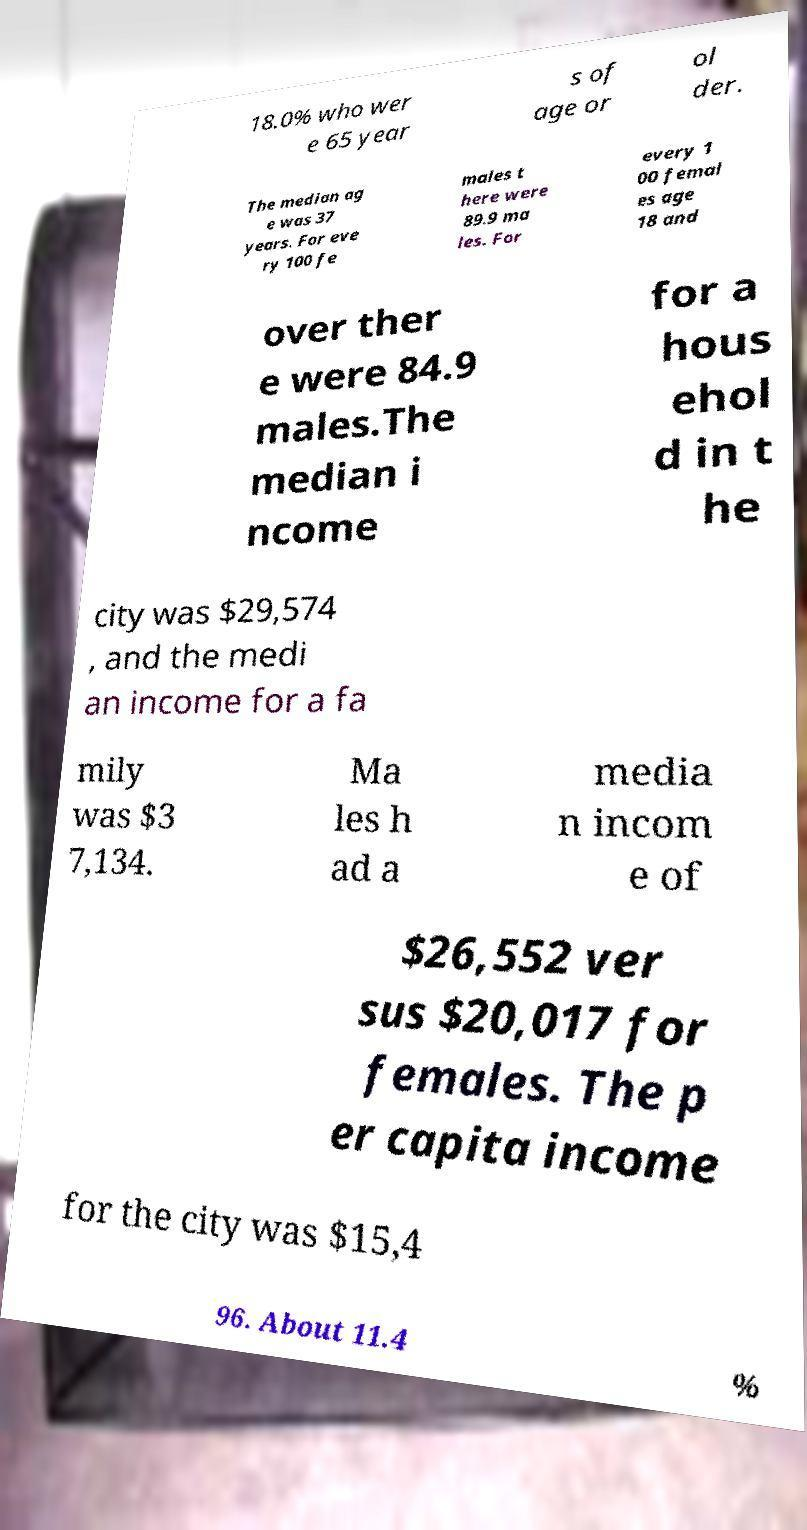For documentation purposes, I need the text within this image transcribed. Could you provide that? 18.0% who wer e 65 year s of age or ol der. The median ag e was 37 years. For eve ry 100 fe males t here were 89.9 ma les. For every 1 00 femal es age 18 and over ther e were 84.9 males.The median i ncome for a hous ehol d in t he city was $29,574 , and the medi an income for a fa mily was $3 7,134. Ma les h ad a media n incom e of $26,552 ver sus $20,017 for females. The p er capita income for the city was $15,4 96. About 11.4 % 